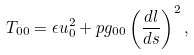<formula> <loc_0><loc_0><loc_500><loc_500>T _ { 0 0 } = \epsilon u _ { 0 } ^ { 2 } + p g _ { 0 0 } \left ( \frac { d l } { d s } \right ) ^ { 2 } ,</formula> 